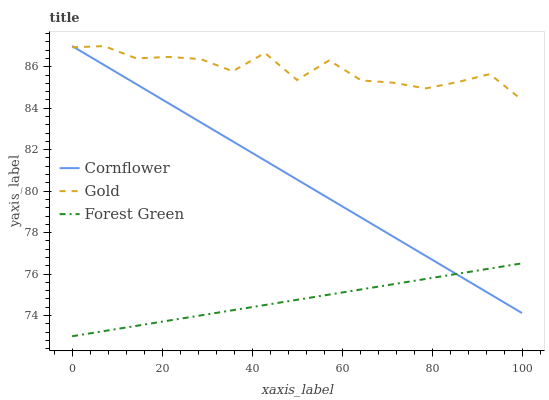Does Forest Green have the minimum area under the curve?
Answer yes or no. Yes. Does Gold have the maximum area under the curve?
Answer yes or no. Yes. Does Gold have the minimum area under the curve?
Answer yes or no. No. Does Forest Green have the maximum area under the curve?
Answer yes or no. No. Is Forest Green the smoothest?
Answer yes or no. Yes. Is Gold the roughest?
Answer yes or no. Yes. Is Gold the smoothest?
Answer yes or no. No. Is Forest Green the roughest?
Answer yes or no. No. Does Forest Green have the lowest value?
Answer yes or no. Yes. Does Gold have the lowest value?
Answer yes or no. No. Does Cornflower have the highest value?
Answer yes or no. Yes. Does Gold have the highest value?
Answer yes or no. No. Is Forest Green less than Gold?
Answer yes or no. Yes. Is Gold greater than Forest Green?
Answer yes or no. Yes. Does Cornflower intersect Gold?
Answer yes or no. Yes. Is Cornflower less than Gold?
Answer yes or no. No. Is Cornflower greater than Gold?
Answer yes or no. No. Does Forest Green intersect Gold?
Answer yes or no. No. 